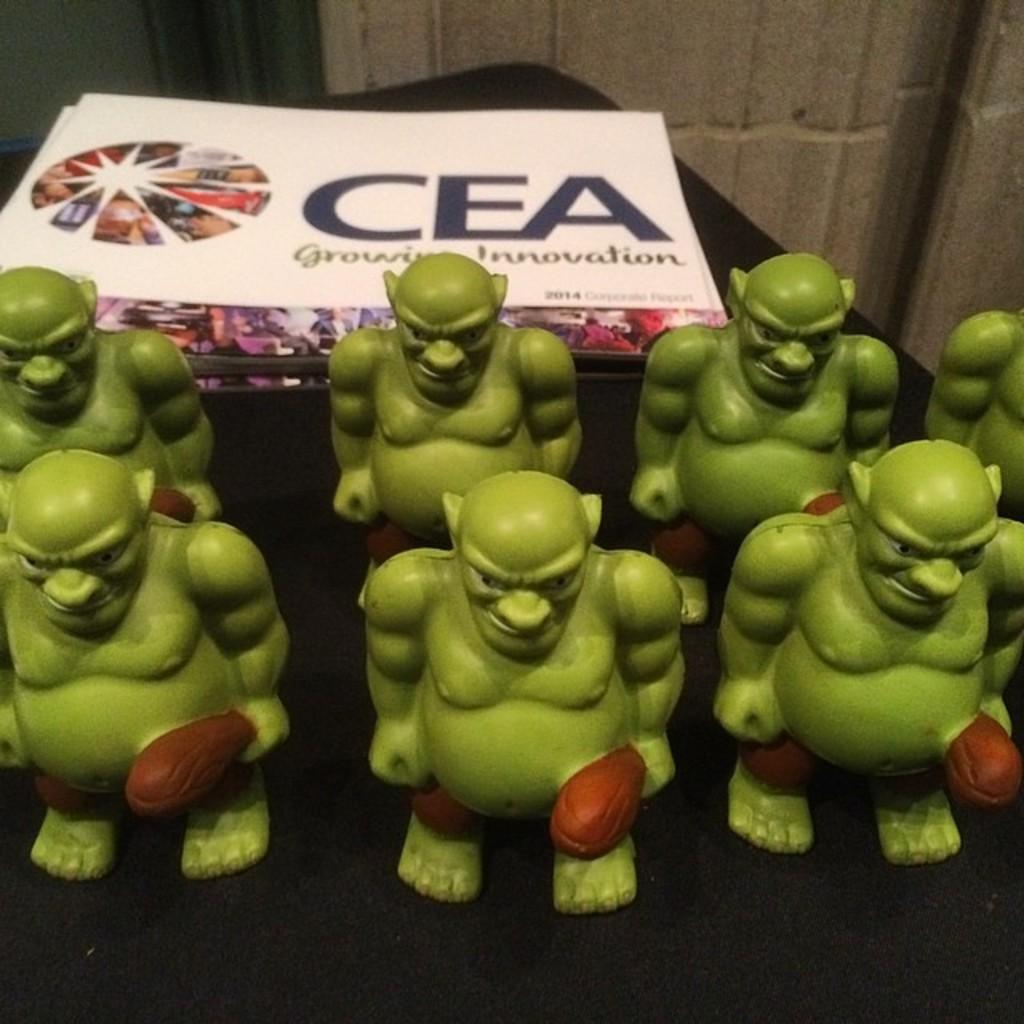What objects are on the table in the image? There are toys on a table in the image. What can be seen in the background of the image? There is a wall visible in the background of the image. What type of pleasure can be seen enjoying the toys in the image? There is no indication of pleasure or any sentient beings in the image; it only features toys on a table and a wall in the background. 